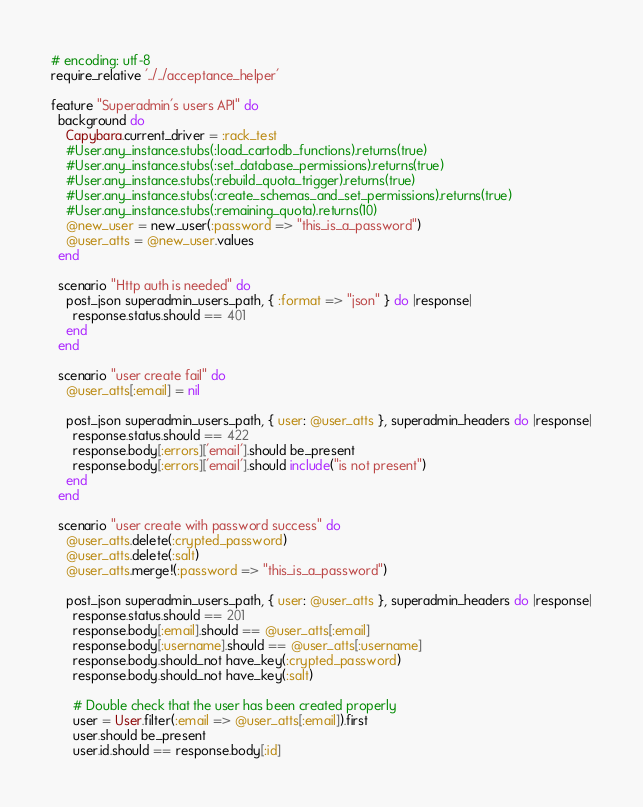<code> <loc_0><loc_0><loc_500><loc_500><_Ruby_># encoding: utf-8
require_relative '../../acceptance_helper'

feature "Superadmin's users API" do
  background do
    Capybara.current_driver = :rack_test
    #User.any_instance.stubs(:load_cartodb_functions).returns(true)
    #User.any_instance.stubs(:set_database_permissions).returns(true)
    #User.any_instance.stubs(:rebuild_quota_trigger).returns(true)
    #User.any_instance.stubs(:create_schemas_and_set_permissions).returns(true)
    #User.any_instance.stubs(:remaining_quota).returns(10)
    @new_user = new_user(:password => "this_is_a_password")
    @user_atts = @new_user.values
  end

  scenario "Http auth is needed" do
    post_json superadmin_users_path, { :format => "json" } do |response|
      response.status.should == 401
    end
  end

  scenario "user create fail" do
    @user_atts[:email] = nil

    post_json superadmin_users_path, { user: @user_atts }, superadmin_headers do |response|
      response.status.should == 422
      response.body[:errors]['email'].should be_present
      response.body[:errors]['email'].should include("is not present")
    end
  end

  scenario "user create with password success" do
    @user_atts.delete(:crypted_password)
    @user_atts.delete(:salt)
    @user_atts.merge!(:password => "this_is_a_password")

    post_json superadmin_users_path, { user: @user_atts }, superadmin_headers do |response|
      response.status.should == 201
      response.body[:email].should == @user_atts[:email]
      response.body[:username].should == @user_atts[:username]
      response.body.should_not have_key(:crypted_password)
      response.body.should_not have_key(:salt)

      # Double check that the user has been created properly
      user = User.filter(:email => @user_atts[:email]).first
      user.should be_present
      user.id.should == response.body[:id]</code> 